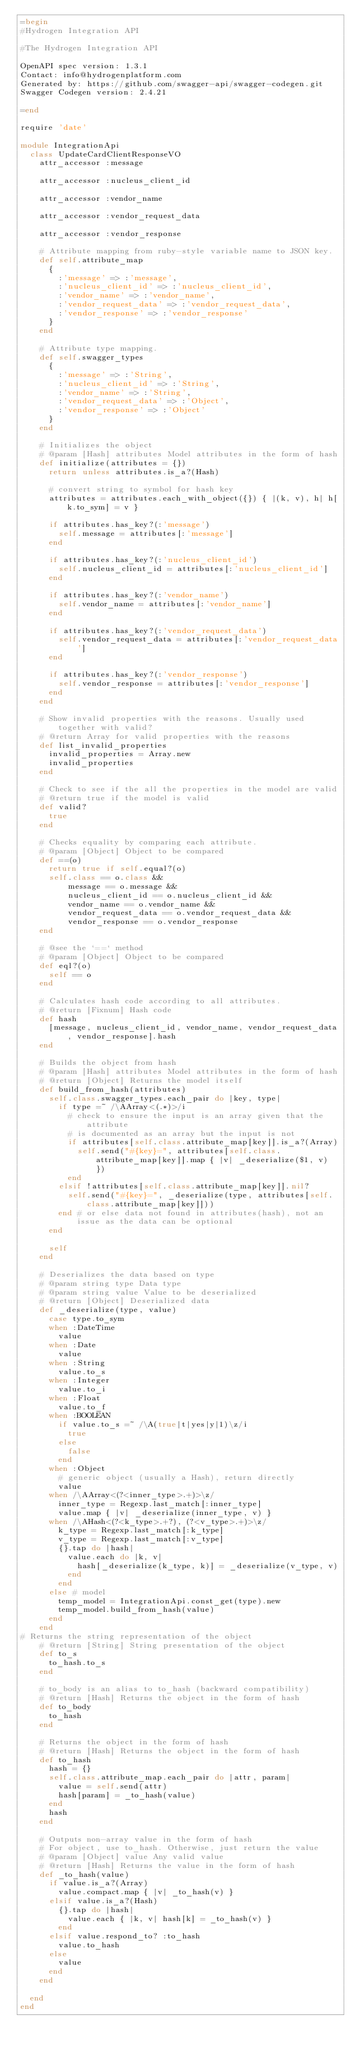Convert code to text. <code><loc_0><loc_0><loc_500><loc_500><_Ruby_>=begin
#Hydrogen Integration API

#The Hydrogen Integration API

OpenAPI spec version: 1.3.1
Contact: info@hydrogenplatform.com
Generated by: https://github.com/swagger-api/swagger-codegen.git
Swagger Codegen version: 2.4.21

=end

require 'date'

module IntegrationApi
  class UpdateCardClientResponseVO
    attr_accessor :message

    attr_accessor :nucleus_client_id

    attr_accessor :vendor_name

    attr_accessor :vendor_request_data

    attr_accessor :vendor_response

    # Attribute mapping from ruby-style variable name to JSON key.
    def self.attribute_map
      {
        :'message' => :'message',
        :'nucleus_client_id' => :'nucleus_client_id',
        :'vendor_name' => :'vendor_name',
        :'vendor_request_data' => :'vendor_request_data',
        :'vendor_response' => :'vendor_response'
      }
    end

    # Attribute type mapping.
    def self.swagger_types
      {
        :'message' => :'String',
        :'nucleus_client_id' => :'String',
        :'vendor_name' => :'String',
        :'vendor_request_data' => :'Object',
        :'vendor_response' => :'Object'
      }
    end

    # Initializes the object
    # @param [Hash] attributes Model attributes in the form of hash
    def initialize(attributes = {})
      return unless attributes.is_a?(Hash)

      # convert string to symbol for hash key
      attributes = attributes.each_with_object({}) { |(k, v), h| h[k.to_sym] = v }

      if attributes.has_key?(:'message')
        self.message = attributes[:'message']
      end

      if attributes.has_key?(:'nucleus_client_id')
        self.nucleus_client_id = attributes[:'nucleus_client_id']
      end

      if attributes.has_key?(:'vendor_name')
        self.vendor_name = attributes[:'vendor_name']
      end

      if attributes.has_key?(:'vendor_request_data')
        self.vendor_request_data = attributes[:'vendor_request_data']
      end

      if attributes.has_key?(:'vendor_response')
        self.vendor_response = attributes[:'vendor_response']
      end
    end

    # Show invalid properties with the reasons. Usually used together with valid?
    # @return Array for valid properties with the reasons
    def list_invalid_properties
      invalid_properties = Array.new
      invalid_properties
    end

    # Check to see if the all the properties in the model are valid
    # @return true if the model is valid
    def valid?
      true
    end

    # Checks equality by comparing each attribute.
    # @param [Object] Object to be compared
    def ==(o)
      return true if self.equal?(o)
      self.class == o.class &&
          message == o.message &&
          nucleus_client_id == o.nucleus_client_id &&
          vendor_name == o.vendor_name &&
          vendor_request_data == o.vendor_request_data &&
          vendor_response == o.vendor_response
    end

    # @see the `==` method
    # @param [Object] Object to be compared
    def eql?(o)
      self == o
    end

    # Calculates hash code according to all attributes.
    # @return [Fixnum] Hash code
    def hash
      [message, nucleus_client_id, vendor_name, vendor_request_data, vendor_response].hash
    end

    # Builds the object from hash
    # @param [Hash] attributes Model attributes in the form of hash
    # @return [Object] Returns the model itself
    def build_from_hash(attributes)
      self.class.swagger_types.each_pair do |key, type|
        if type =~ /\AArray<(.*)>/i
          # check to ensure the input is an array given that the attribute
          # is documented as an array but the input is not
          if attributes[self.class.attribute_map[key]].is_a?(Array)
            self.send("#{key}=", attributes[self.class.attribute_map[key]].map { |v| _deserialize($1, v) })
          end
        elsif !attributes[self.class.attribute_map[key]].nil?
          self.send("#{key}=", _deserialize(type, attributes[self.class.attribute_map[key]]))
        end # or else data not found in attributes(hash), not an issue as the data can be optional
      end

      self
    end

    # Deserializes the data based on type
    # @param string type Data type
    # @param string value Value to be deserialized
    # @return [Object] Deserialized data
    def _deserialize(type, value)
      case type.to_sym
      when :DateTime
        value
      when :Date
        value
      when :String
        value.to_s
      when :Integer
        value.to_i
      when :Float
        value.to_f
      when :BOOLEAN
        if value.to_s =~ /\A(true|t|yes|y|1)\z/i
          true
        else
          false
        end
      when :Object
        # generic object (usually a Hash), return directly
        value
      when /\AArray<(?<inner_type>.+)>\z/
        inner_type = Regexp.last_match[:inner_type]
        value.map { |v| _deserialize(inner_type, v) }
      when /\AHash<(?<k_type>.+?), (?<v_type>.+)>\z/
        k_type = Regexp.last_match[:k_type]
        v_type = Regexp.last_match[:v_type]
        {}.tap do |hash|
          value.each do |k, v|
            hash[_deserialize(k_type, k)] = _deserialize(v_type, v)
          end
        end
      else # model
        temp_model = IntegrationApi.const_get(type).new
        temp_model.build_from_hash(value)
      end
    end
# Returns the string representation of the object
    # @return [String] String presentation of the object
    def to_s
      to_hash.to_s
    end

    # to_body is an alias to to_hash (backward compatibility)
    # @return [Hash] Returns the object in the form of hash
    def to_body
      to_hash
    end

    # Returns the object in the form of hash
    # @return [Hash] Returns the object in the form of hash
    def to_hash
      hash = {}
      self.class.attribute_map.each_pair do |attr, param|
        value = self.send(attr)
        hash[param] = _to_hash(value)
      end
      hash
    end

    # Outputs non-array value in the form of hash
    # For object, use to_hash. Otherwise, just return the value
    # @param [Object] value Any valid value
    # @return [Hash] Returns the value in the form of hash
    def _to_hash(value)
      if value.is_a?(Array)
        value.compact.map { |v| _to_hash(v) }
      elsif value.is_a?(Hash)
        {}.tap do |hash|
          value.each { |k, v| hash[k] = _to_hash(v) }
        end
      elsif value.respond_to? :to_hash
        value.to_hash
      else
        value
      end
    end

  end
end
</code> 